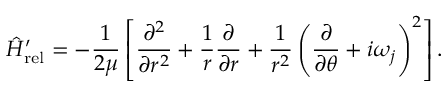Convert formula to latex. <formula><loc_0><loc_0><loc_500><loc_500>\hat { H } _ { r e l } ^ { \prime } = - \frac { 1 } { 2 \mu } \left [ \frac { \partial ^ { 2 } } { \partial r ^ { 2 } } + \frac { 1 } { r } \frac { \partial } { \partial r } + \frac { 1 } { r ^ { 2 } } \left ( \frac { \partial } { \partial \theta } + i \omega _ { j } \right ) ^ { 2 } \right ] .</formula> 